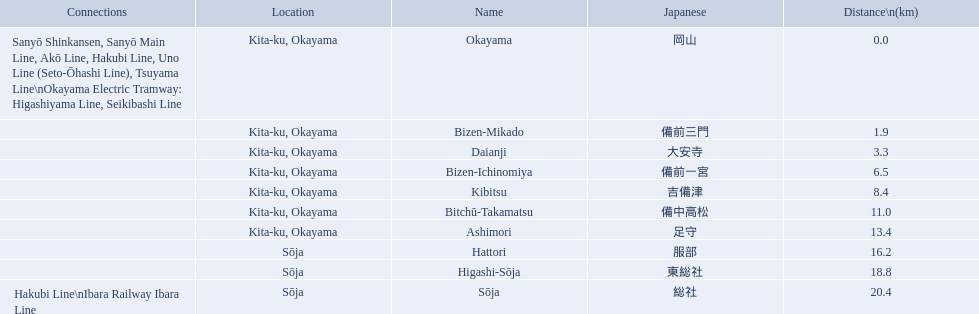What are all of the train names? Okayama, Bizen-Mikado, Daianji, Bizen-Ichinomiya, Kibitsu, Bitchū-Takamatsu, Ashimori, Hattori, Higashi-Sōja, Sōja. What is the distance for each? 0.0, 1.9, 3.3, 6.5, 8.4, 11.0, 13.4, 16.2, 18.8, 20.4. And which train's distance is between 1 and 2 km? Bizen-Mikado. 